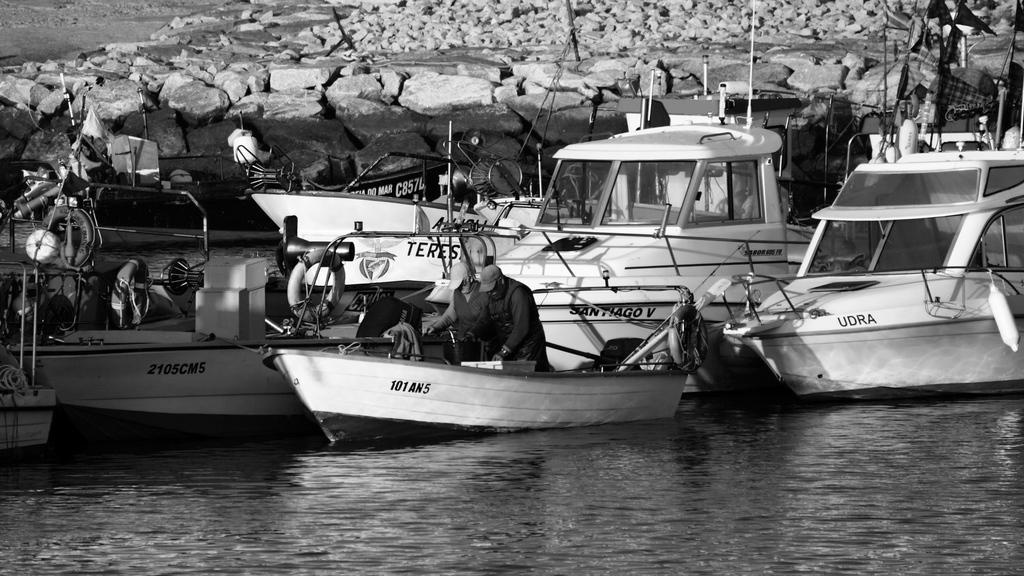What number is on either of the boats?
Ensure brevity in your answer.  Unanswerable. 